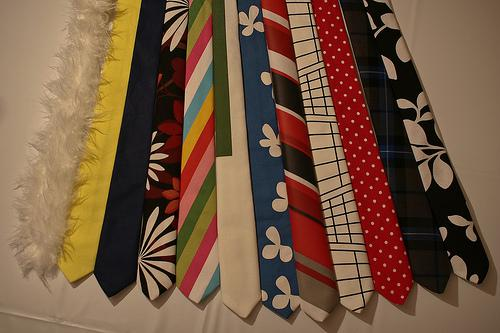Question: what are in the picture?
Choices:
A. Suits.
B. Tuxedos.
C. Ties.
D. Watches.
Answer with the letter. Answer: C Question: what pattern is on the red tie?
Choices:
A. Stripes.
B. Plain color.
C. Polka dot.
D. Colorful diamonds.
Answer with the letter. Answer: C Question: what fabric is the white tie made of?
Choices:
A. Fur.
B. Leather.
C. Bamboo.
D. Silk.
Answer with the letter. Answer: A Question: how many solid yellow ties are there?
Choices:
A. 3.
B. 1.
C. 4.
D. 6.
Answer with the letter. Answer: B Question: what color tie is between the fur and navy ties?
Choices:
A. Black.
B. Yellow.
C. White.
D. Purple.
Answer with the letter. Answer: B Question: how many ties have stripes only?
Choices:
A. 1.
B. 3.
C. 6.
D. 2.
Answer with the letter. Answer: D Question: where is the black and white tie?
Choices:
A. The front.
B. The back.
C. The end.
D. The middle.
Answer with the letter. Answer: C 